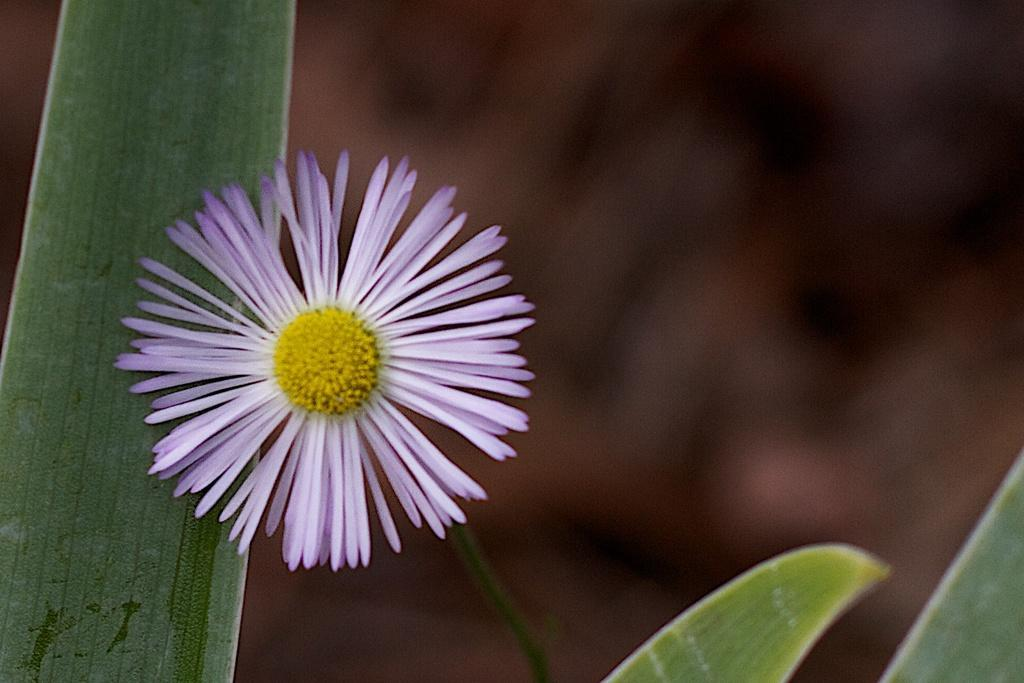What can be observed about the background of the image? The background portion of the picture is blurred. What type of vegetation is present in the image? There are green leaves in the image. What is the main subject of the image? There is a flower in the image. What connects the flower to the leaves? There is a stem in the image. Can you tell me how many lamps are present in the image? There are no lamps present in the image; it features a flower, green leaves, and a stem. What type of porter is shown carrying the flower in the image? There is no porter present in the image; it is a still image of a flower, leaves, and stem. 